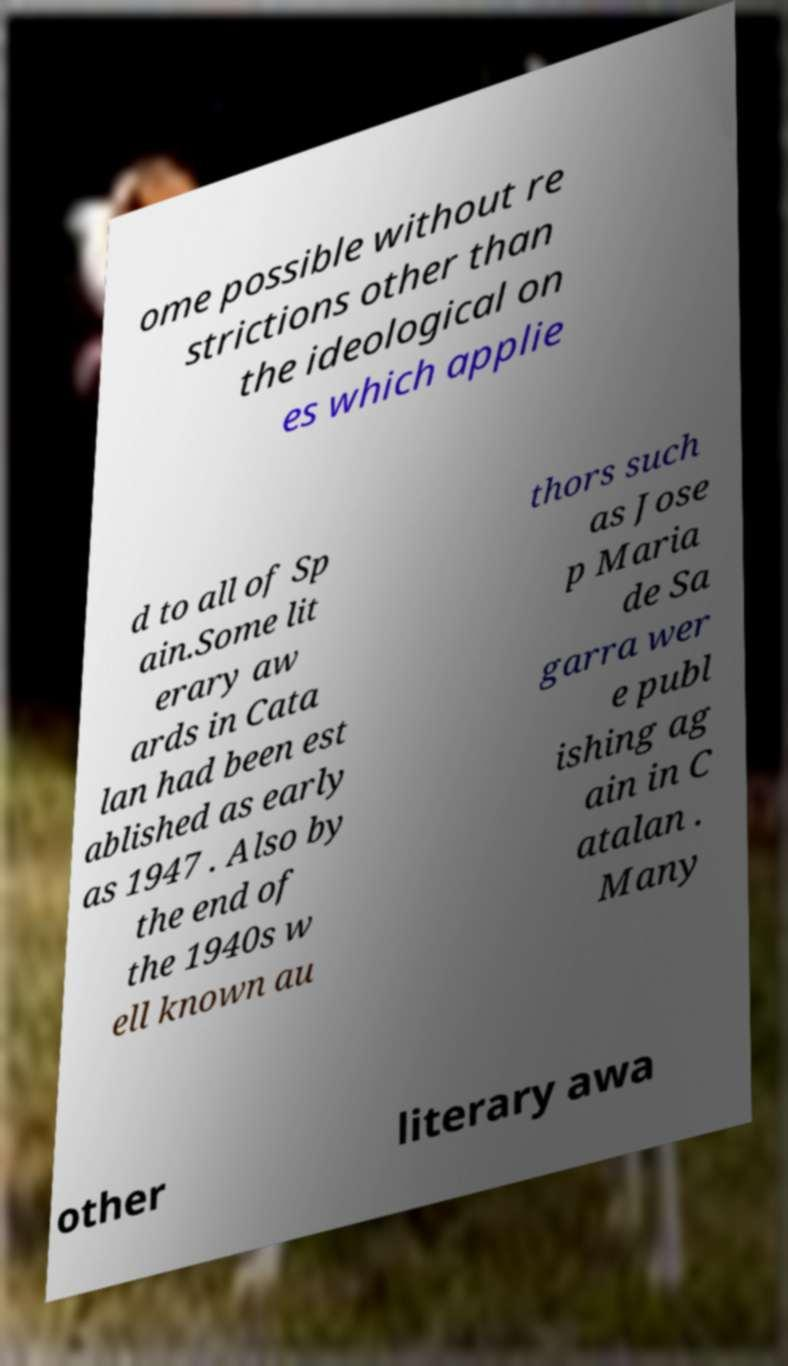Could you extract and type out the text from this image? ome possible without re strictions other than the ideological on es which applie d to all of Sp ain.Some lit erary aw ards in Cata lan had been est ablished as early as 1947 . Also by the end of the 1940s w ell known au thors such as Jose p Maria de Sa garra wer e publ ishing ag ain in C atalan . Many other literary awa 